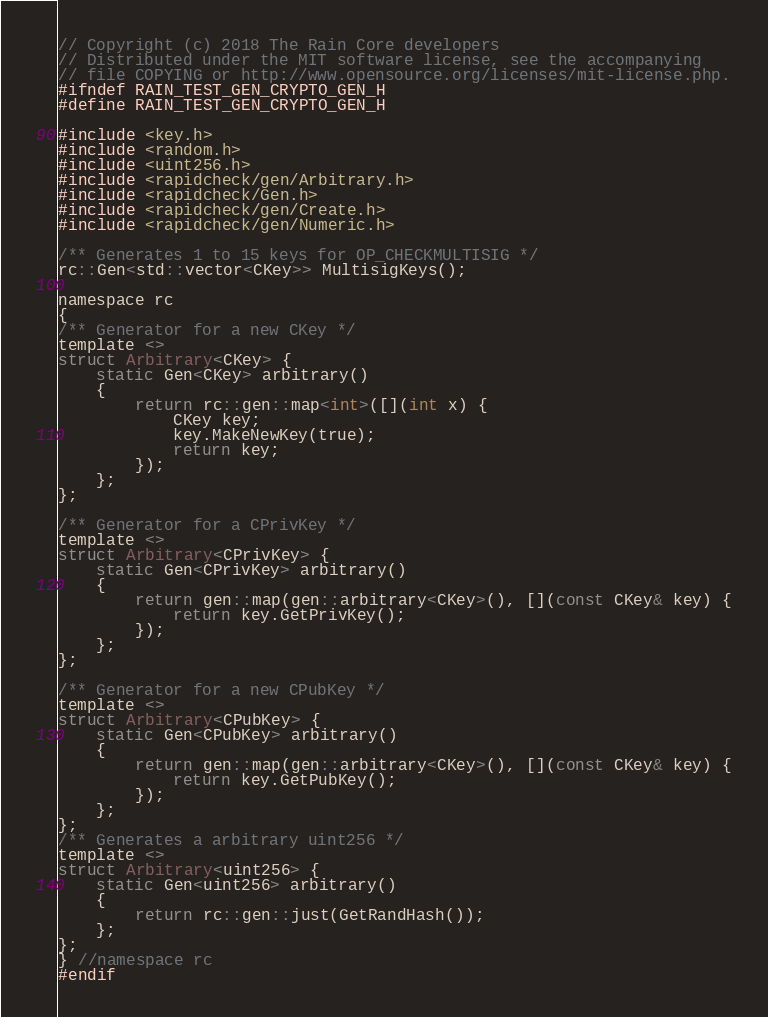<code> <loc_0><loc_0><loc_500><loc_500><_C_>// Copyright (c) 2018 The Rain Core developers
// Distributed under the MIT software license, see the accompanying
// file COPYING or http://www.opensource.org/licenses/mit-license.php.
#ifndef RAIN_TEST_GEN_CRYPTO_GEN_H
#define RAIN_TEST_GEN_CRYPTO_GEN_H

#include <key.h>
#include <random.h>
#include <uint256.h>
#include <rapidcheck/gen/Arbitrary.h>
#include <rapidcheck/Gen.h>
#include <rapidcheck/gen/Create.h>
#include <rapidcheck/gen/Numeric.h>

/** Generates 1 to 15 keys for OP_CHECKMULTISIG */
rc::Gen<std::vector<CKey>> MultisigKeys();

namespace rc
{
/** Generator for a new CKey */
template <>
struct Arbitrary<CKey> {
    static Gen<CKey> arbitrary()
    {
        return rc::gen::map<int>([](int x) {
            CKey key;
            key.MakeNewKey(true);
            return key;
        });
    };
};

/** Generator for a CPrivKey */
template <>
struct Arbitrary<CPrivKey> {
    static Gen<CPrivKey> arbitrary()
    {
        return gen::map(gen::arbitrary<CKey>(), [](const CKey& key) {
            return key.GetPrivKey();
        });
    };
};

/** Generator for a new CPubKey */
template <>
struct Arbitrary<CPubKey> {
    static Gen<CPubKey> arbitrary()
    {
        return gen::map(gen::arbitrary<CKey>(), [](const CKey& key) {
            return key.GetPubKey();
        });
    };
};
/** Generates a arbitrary uint256 */
template <>
struct Arbitrary<uint256> {
    static Gen<uint256> arbitrary()
    {
        return rc::gen::just(GetRandHash());
    };
};
} //namespace rc
#endif
</code> 